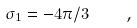<formula> <loc_0><loc_0><loc_500><loc_500>\sigma _ { 1 } = - 4 \pi / 3 \quad ,</formula> 